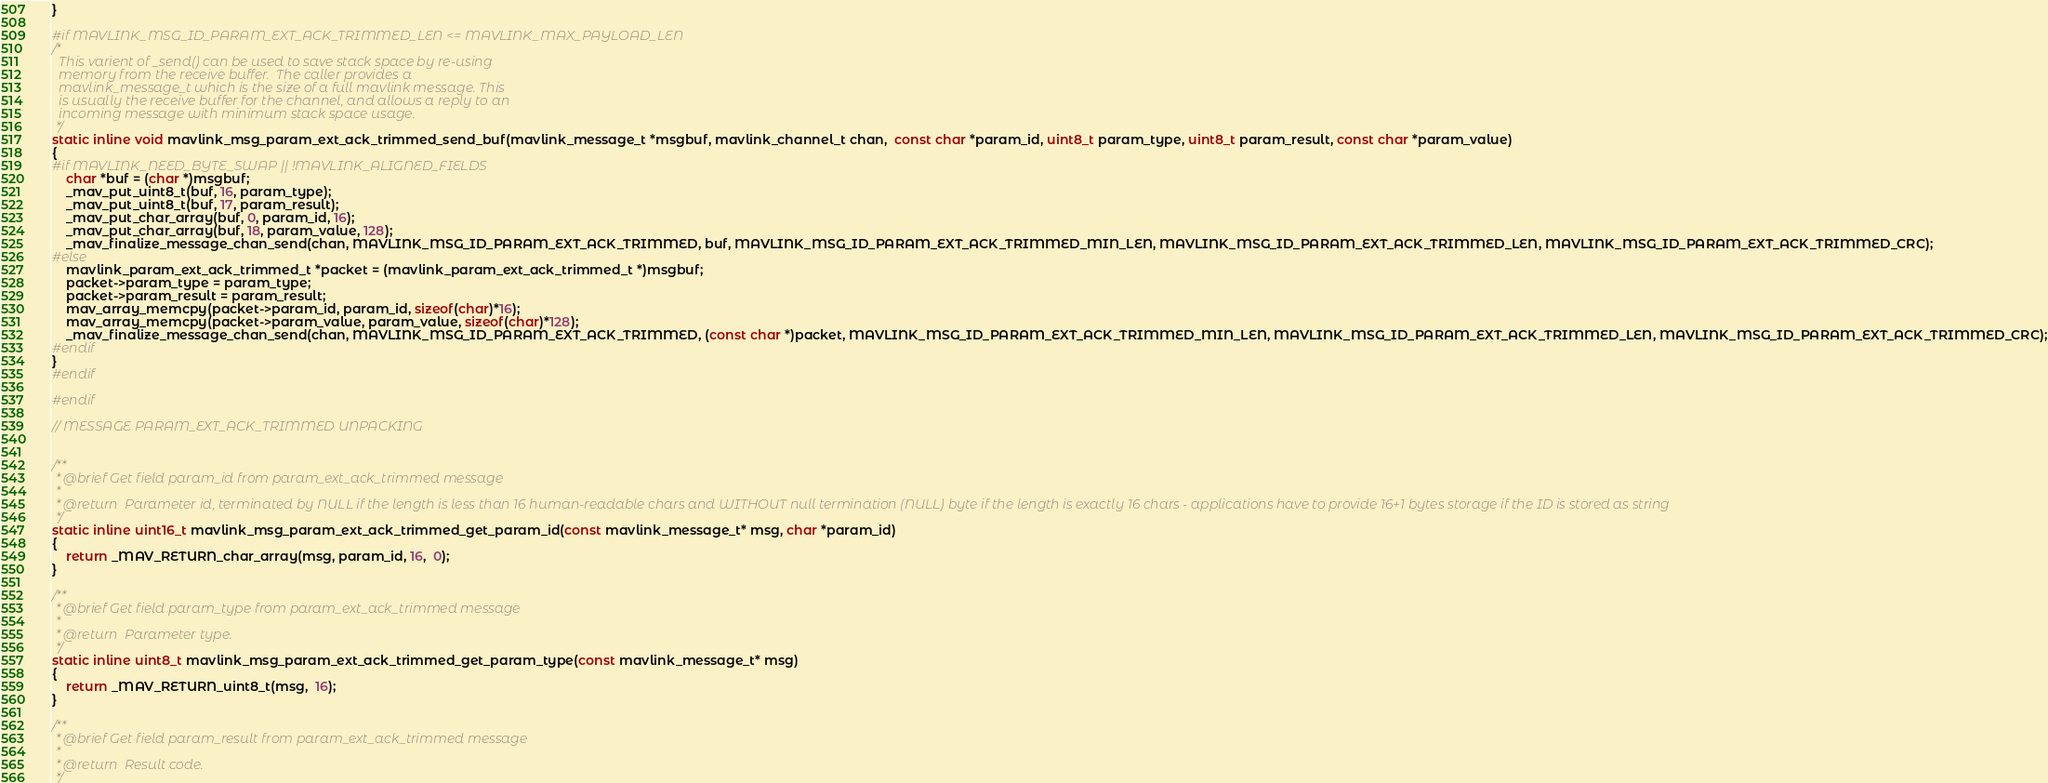<code> <loc_0><loc_0><loc_500><loc_500><_C_>}

#if MAVLINK_MSG_ID_PARAM_EXT_ACK_TRIMMED_LEN <= MAVLINK_MAX_PAYLOAD_LEN
/*
  This varient of _send() can be used to save stack space by re-using
  memory from the receive buffer.  The caller provides a
  mavlink_message_t which is the size of a full mavlink message. This
  is usually the receive buffer for the channel, and allows a reply to an
  incoming message with minimum stack space usage.
 */
static inline void mavlink_msg_param_ext_ack_trimmed_send_buf(mavlink_message_t *msgbuf, mavlink_channel_t chan,  const char *param_id, uint8_t param_type, uint8_t param_result, const char *param_value)
{
#if MAVLINK_NEED_BYTE_SWAP || !MAVLINK_ALIGNED_FIELDS
    char *buf = (char *)msgbuf;
    _mav_put_uint8_t(buf, 16, param_type);
    _mav_put_uint8_t(buf, 17, param_result);
    _mav_put_char_array(buf, 0, param_id, 16);
    _mav_put_char_array(buf, 18, param_value, 128);
    _mav_finalize_message_chan_send(chan, MAVLINK_MSG_ID_PARAM_EXT_ACK_TRIMMED, buf, MAVLINK_MSG_ID_PARAM_EXT_ACK_TRIMMED_MIN_LEN, MAVLINK_MSG_ID_PARAM_EXT_ACK_TRIMMED_LEN, MAVLINK_MSG_ID_PARAM_EXT_ACK_TRIMMED_CRC);
#else
    mavlink_param_ext_ack_trimmed_t *packet = (mavlink_param_ext_ack_trimmed_t *)msgbuf;
    packet->param_type = param_type;
    packet->param_result = param_result;
    mav_array_memcpy(packet->param_id, param_id, sizeof(char)*16);
    mav_array_memcpy(packet->param_value, param_value, sizeof(char)*128);
    _mav_finalize_message_chan_send(chan, MAVLINK_MSG_ID_PARAM_EXT_ACK_TRIMMED, (const char *)packet, MAVLINK_MSG_ID_PARAM_EXT_ACK_TRIMMED_MIN_LEN, MAVLINK_MSG_ID_PARAM_EXT_ACK_TRIMMED_LEN, MAVLINK_MSG_ID_PARAM_EXT_ACK_TRIMMED_CRC);
#endif
}
#endif

#endif

// MESSAGE PARAM_EXT_ACK_TRIMMED UNPACKING


/**
 * @brief Get field param_id from param_ext_ack_trimmed message
 *
 * @return  Parameter id, terminated by NULL if the length is less than 16 human-readable chars and WITHOUT null termination (NULL) byte if the length is exactly 16 chars - applications have to provide 16+1 bytes storage if the ID is stored as string
 */
static inline uint16_t mavlink_msg_param_ext_ack_trimmed_get_param_id(const mavlink_message_t* msg, char *param_id)
{
    return _MAV_RETURN_char_array(msg, param_id, 16,  0);
}

/**
 * @brief Get field param_type from param_ext_ack_trimmed message
 *
 * @return  Parameter type.
 */
static inline uint8_t mavlink_msg_param_ext_ack_trimmed_get_param_type(const mavlink_message_t* msg)
{
    return _MAV_RETURN_uint8_t(msg,  16);
}

/**
 * @brief Get field param_result from param_ext_ack_trimmed message
 *
 * @return  Result code.
 */</code> 